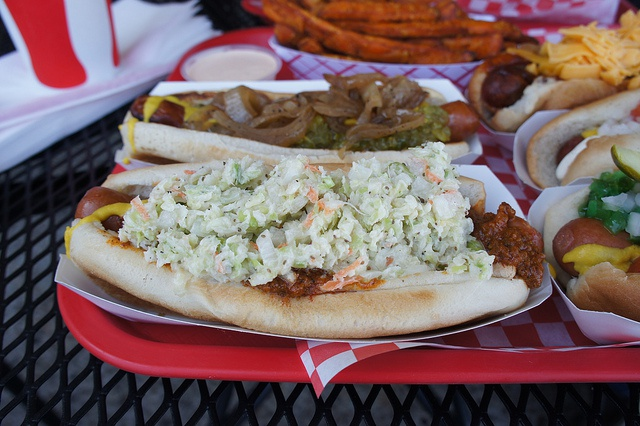Describe the objects in this image and their specific colors. I can see hot dog in lightblue, darkgray, lightgray, and tan tones, hot dog in lightblue, maroon, darkgray, and gray tones, cup in lightblue, brown, and lavender tones, hot dog in lightblue, darkgray, and gray tones, and hot dog in lightblue, maroon, black, darkgray, and gray tones in this image. 